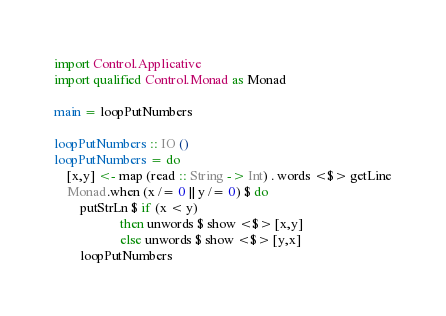<code> <loc_0><loc_0><loc_500><loc_500><_Haskell_>import Control.Applicative
import qualified Control.Monad as Monad

main = loopPutNumbers

loopPutNumbers :: IO ()
loopPutNumbers = do
    [x,y] <- map (read :: String -> Int) . words <$> getLine
    Monad.when (x /= 0 || y /= 0) $ do
        putStrLn $ if (x < y)
                    then unwords $ show <$> [x,y]
                    else unwords $ show <$> [y,x]
        loopPutNumbers
</code> 